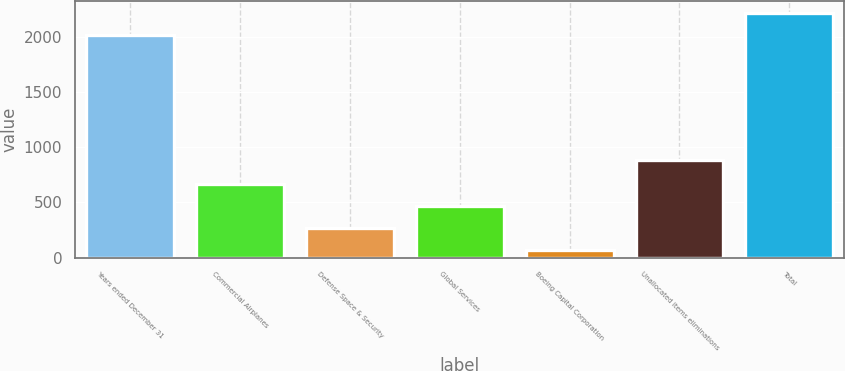<chart> <loc_0><loc_0><loc_500><loc_500><bar_chart><fcel>Years ended December 31<fcel>Commercial Airplanes<fcel>Defense Space & Security<fcel>Global Services<fcel>Boeing Capital Corporation<fcel>Unallocated items eliminations<fcel>Total<nl><fcel>2017<fcel>663.1<fcel>267.7<fcel>465.4<fcel>70<fcel>882<fcel>2214.7<nl></chart> 